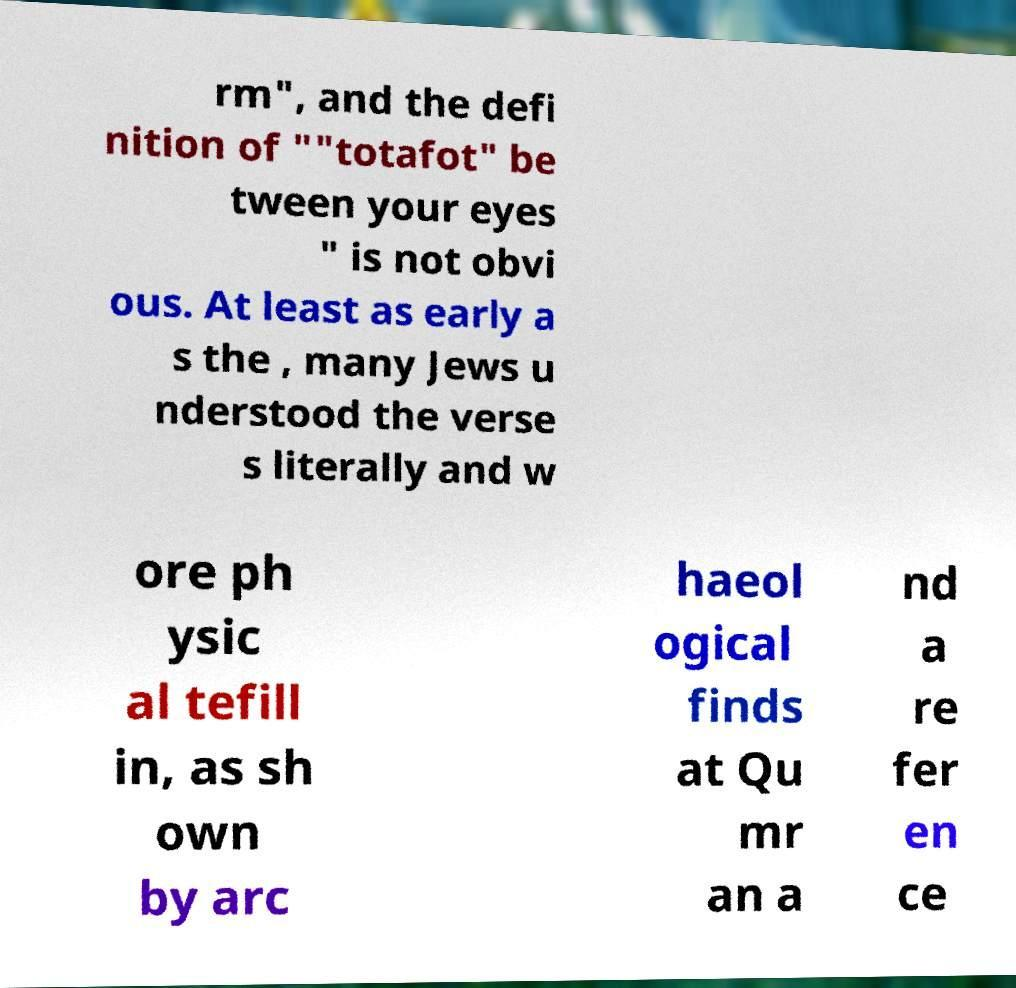Please identify and transcribe the text found in this image. rm", and the defi nition of ""totafot" be tween your eyes " is not obvi ous. At least as early a s the , many Jews u nderstood the verse s literally and w ore ph ysic al tefill in, as sh own by arc haeol ogical finds at Qu mr an a nd a re fer en ce 